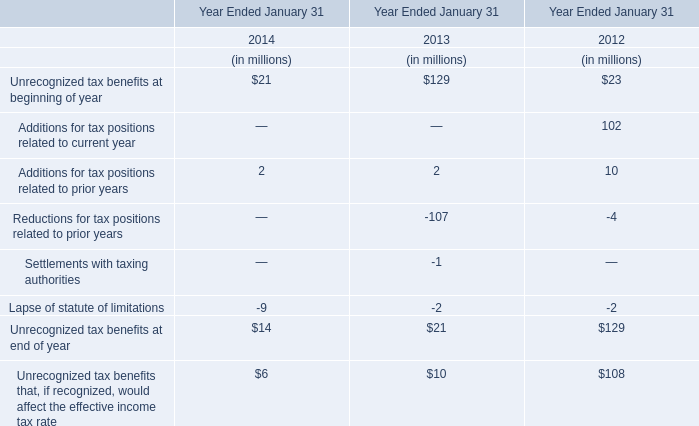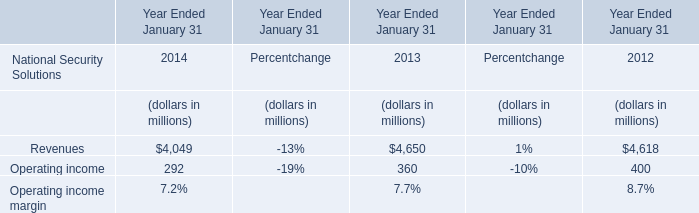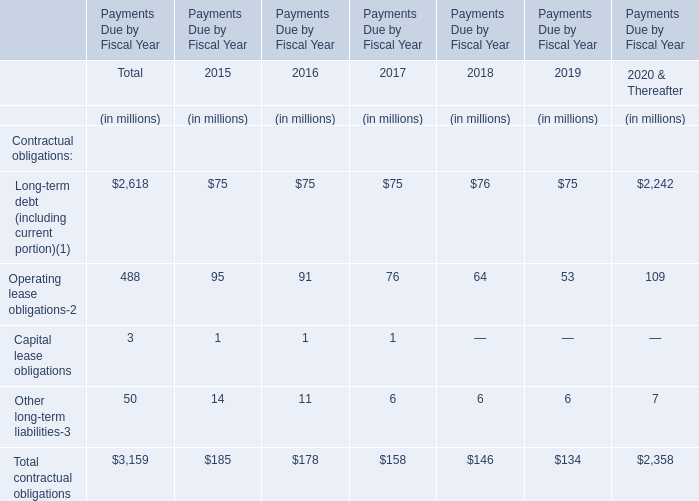What is the sum of Operating lease obligations in 2017 and Unrecognized tax benefits at end of year in 2012? (in million) 
Computations: (76 + 129)
Answer: 205.0. 